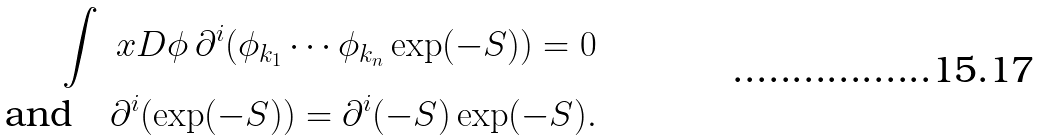Convert formula to latex. <formula><loc_0><loc_0><loc_500><loc_500>\int \ x D \phi \, \partial ^ { i } ( \phi _ { k _ { 1 } } \cdots \phi _ { k _ { n } } \exp ( - S ) ) = 0 \\ \text {and} \quad \partial ^ { i } ( \exp ( - S ) ) = \partial ^ { i } ( - S ) \exp ( - S ) .</formula> 